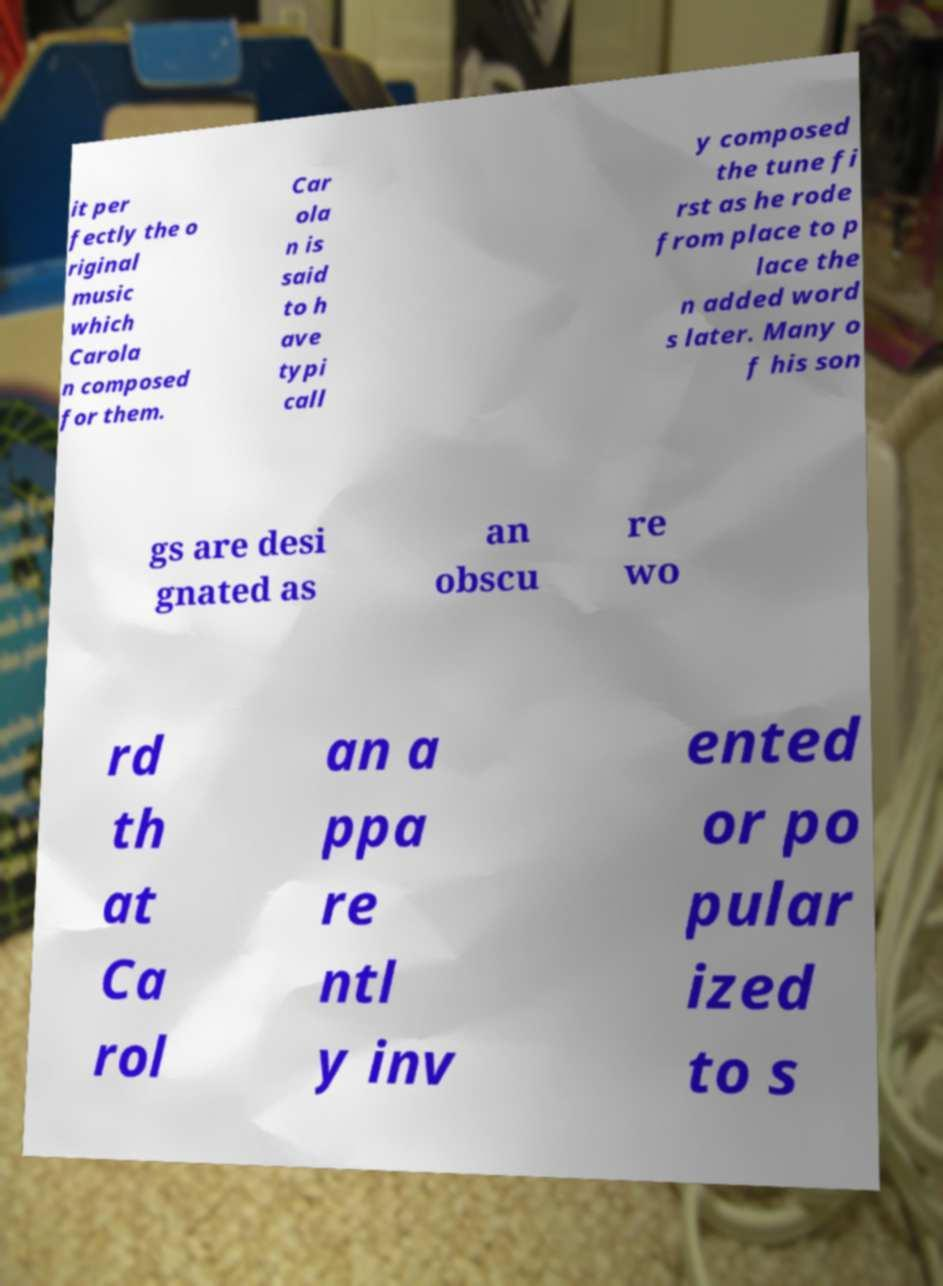There's text embedded in this image that I need extracted. Can you transcribe it verbatim? it per fectly the o riginal music which Carola n composed for them. Car ola n is said to h ave typi call y composed the tune fi rst as he rode from place to p lace the n added word s later. Many o f his son gs are desi gnated as an obscu re wo rd th at Ca rol an a ppa re ntl y inv ented or po pular ized to s 